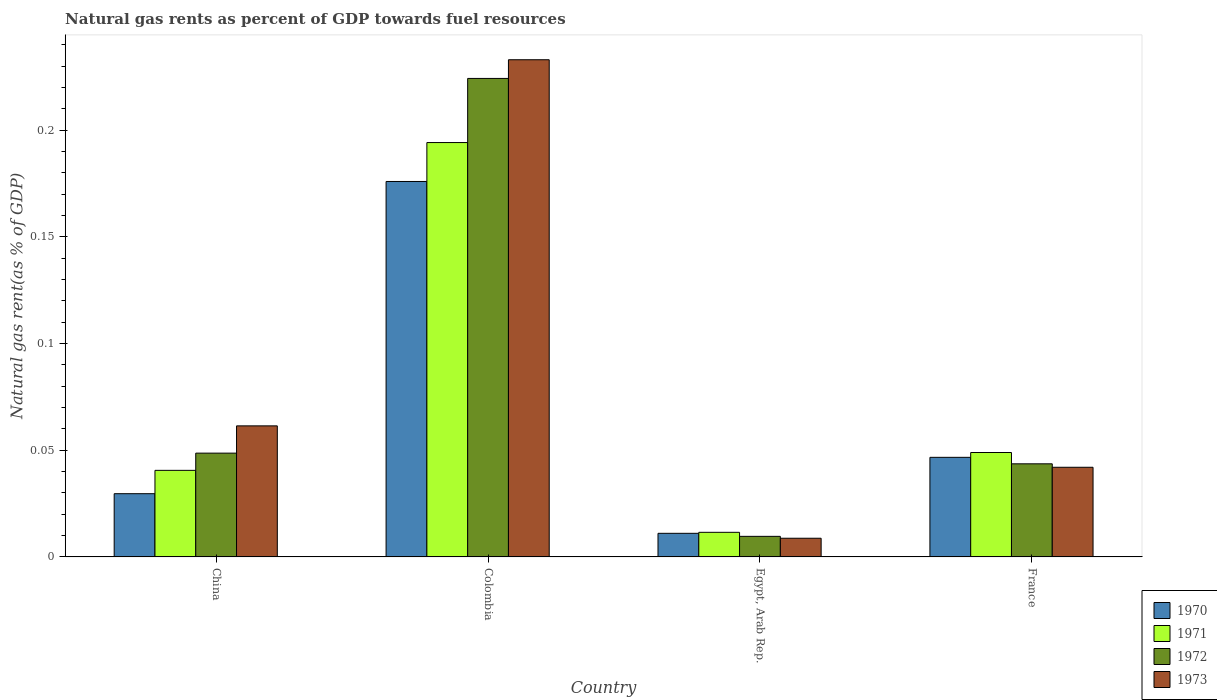How many groups of bars are there?
Ensure brevity in your answer.  4. How many bars are there on the 4th tick from the right?
Your response must be concise. 4. What is the label of the 4th group of bars from the left?
Provide a succinct answer. France. In how many cases, is the number of bars for a given country not equal to the number of legend labels?
Your answer should be compact. 0. What is the natural gas rent in 1973 in China?
Make the answer very short. 0.06. Across all countries, what is the maximum natural gas rent in 1973?
Offer a very short reply. 0.23. Across all countries, what is the minimum natural gas rent in 1973?
Offer a terse response. 0.01. In which country was the natural gas rent in 1970 maximum?
Offer a terse response. Colombia. In which country was the natural gas rent in 1972 minimum?
Offer a terse response. Egypt, Arab Rep. What is the total natural gas rent in 1973 in the graph?
Offer a terse response. 0.35. What is the difference between the natural gas rent in 1973 in China and that in Egypt, Arab Rep.?
Your response must be concise. 0.05. What is the difference between the natural gas rent in 1973 in China and the natural gas rent in 1971 in France?
Your response must be concise. 0.01. What is the average natural gas rent in 1971 per country?
Provide a short and direct response. 0.07. What is the difference between the natural gas rent of/in 1971 and natural gas rent of/in 1970 in Colombia?
Offer a terse response. 0.02. In how many countries, is the natural gas rent in 1971 greater than 0.04 %?
Offer a terse response. 3. What is the ratio of the natural gas rent in 1971 in China to that in France?
Offer a very short reply. 0.83. What is the difference between the highest and the second highest natural gas rent in 1970?
Offer a very short reply. 0.15. What is the difference between the highest and the lowest natural gas rent in 1971?
Provide a short and direct response. 0.18. Is it the case that in every country, the sum of the natural gas rent in 1972 and natural gas rent in 1970 is greater than the sum of natural gas rent in 1971 and natural gas rent in 1973?
Your answer should be compact. No. What does the 2nd bar from the right in Egypt, Arab Rep. represents?
Offer a terse response. 1972. How many countries are there in the graph?
Provide a succinct answer. 4. What is the difference between two consecutive major ticks on the Y-axis?
Provide a succinct answer. 0.05. Are the values on the major ticks of Y-axis written in scientific E-notation?
Provide a succinct answer. No. Does the graph contain any zero values?
Offer a terse response. No. Does the graph contain grids?
Your answer should be compact. No. Where does the legend appear in the graph?
Offer a very short reply. Bottom right. How many legend labels are there?
Your answer should be compact. 4. How are the legend labels stacked?
Provide a short and direct response. Vertical. What is the title of the graph?
Your answer should be compact. Natural gas rents as percent of GDP towards fuel resources. What is the label or title of the Y-axis?
Provide a short and direct response. Natural gas rent(as % of GDP). What is the Natural gas rent(as % of GDP) of 1970 in China?
Make the answer very short. 0.03. What is the Natural gas rent(as % of GDP) in 1971 in China?
Offer a very short reply. 0.04. What is the Natural gas rent(as % of GDP) of 1972 in China?
Give a very brief answer. 0.05. What is the Natural gas rent(as % of GDP) in 1973 in China?
Offer a terse response. 0.06. What is the Natural gas rent(as % of GDP) in 1970 in Colombia?
Your answer should be compact. 0.18. What is the Natural gas rent(as % of GDP) in 1971 in Colombia?
Offer a very short reply. 0.19. What is the Natural gas rent(as % of GDP) in 1972 in Colombia?
Your answer should be very brief. 0.22. What is the Natural gas rent(as % of GDP) of 1973 in Colombia?
Give a very brief answer. 0.23. What is the Natural gas rent(as % of GDP) in 1970 in Egypt, Arab Rep.?
Offer a very short reply. 0.01. What is the Natural gas rent(as % of GDP) of 1971 in Egypt, Arab Rep.?
Keep it short and to the point. 0.01. What is the Natural gas rent(as % of GDP) in 1972 in Egypt, Arab Rep.?
Offer a terse response. 0.01. What is the Natural gas rent(as % of GDP) in 1973 in Egypt, Arab Rep.?
Keep it short and to the point. 0.01. What is the Natural gas rent(as % of GDP) in 1970 in France?
Give a very brief answer. 0.05. What is the Natural gas rent(as % of GDP) of 1971 in France?
Your response must be concise. 0.05. What is the Natural gas rent(as % of GDP) of 1972 in France?
Offer a very short reply. 0.04. What is the Natural gas rent(as % of GDP) in 1973 in France?
Provide a short and direct response. 0.04. Across all countries, what is the maximum Natural gas rent(as % of GDP) in 1970?
Offer a terse response. 0.18. Across all countries, what is the maximum Natural gas rent(as % of GDP) of 1971?
Offer a very short reply. 0.19. Across all countries, what is the maximum Natural gas rent(as % of GDP) of 1972?
Offer a terse response. 0.22. Across all countries, what is the maximum Natural gas rent(as % of GDP) of 1973?
Your answer should be very brief. 0.23. Across all countries, what is the minimum Natural gas rent(as % of GDP) in 1970?
Provide a short and direct response. 0.01. Across all countries, what is the minimum Natural gas rent(as % of GDP) of 1971?
Provide a succinct answer. 0.01. Across all countries, what is the minimum Natural gas rent(as % of GDP) of 1972?
Give a very brief answer. 0.01. Across all countries, what is the minimum Natural gas rent(as % of GDP) of 1973?
Make the answer very short. 0.01. What is the total Natural gas rent(as % of GDP) in 1970 in the graph?
Make the answer very short. 0.26. What is the total Natural gas rent(as % of GDP) in 1971 in the graph?
Give a very brief answer. 0.3. What is the total Natural gas rent(as % of GDP) of 1972 in the graph?
Make the answer very short. 0.33. What is the total Natural gas rent(as % of GDP) in 1973 in the graph?
Offer a terse response. 0.35. What is the difference between the Natural gas rent(as % of GDP) of 1970 in China and that in Colombia?
Your response must be concise. -0.15. What is the difference between the Natural gas rent(as % of GDP) of 1971 in China and that in Colombia?
Your answer should be compact. -0.15. What is the difference between the Natural gas rent(as % of GDP) of 1972 in China and that in Colombia?
Your response must be concise. -0.18. What is the difference between the Natural gas rent(as % of GDP) in 1973 in China and that in Colombia?
Your answer should be compact. -0.17. What is the difference between the Natural gas rent(as % of GDP) in 1970 in China and that in Egypt, Arab Rep.?
Offer a terse response. 0.02. What is the difference between the Natural gas rent(as % of GDP) in 1971 in China and that in Egypt, Arab Rep.?
Your answer should be compact. 0.03. What is the difference between the Natural gas rent(as % of GDP) of 1972 in China and that in Egypt, Arab Rep.?
Make the answer very short. 0.04. What is the difference between the Natural gas rent(as % of GDP) of 1973 in China and that in Egypt, Arab Rep.?
Offer a very short reply. 0.05. What is the difference between the Natural gas rent(as % of GDP) of 1970 in China and that in France?
Ensure brevity in your answer.  -0.02. What is the difference between the Natural gas rent(as % of GDP) in 1971 in China and that in France?
Provide a succinct answer. -0.01. What is the difference between the Natural gas rent(as % of GDP) of 1972 in China and that in France?
Provide a short and direct response. 0.01. What is the difference between the Natural gas rent(as % of GDP) in 1973 in China and that in France?
Provide a short and direct response. 0.02. What is the difference between the Natural gas rent(as % of GDP) in 1970 in Colombia and that in Egypt, Arab Rep.?
Your response must be concise. 0.16. What is the difference between the Natural gas rent(as % of GDP) in 1971 in Colombia and that in Egypt, Arab Rep.?
Your response must be concise. 0.18. What is the difference between the Natural gas rent(as % of GDP) of 1972 in Colombia and that in Egypt, Arab Rep.?
Offer a terse response. 0.21. What is the difference between the Natural gas rent(as % of GDP) of 1973 in Colombia and that in Egypt, Arab Rep.?
Provide a succinct answer. 0.22. What is the difference between the Natural gas rent(as % of GDP) in 1970 in Colombia and that in France?
Offer a very short reply. 0.13. What is the difference between the Natural gas rent(as % of GDP) in 1971 in Colombia and that in France?
Keep it short and to the point. 0.15. What is the difference between the Natural gas rent(as % of GDP) in 1972 in Colombia and that in France?
Your answer should be compact. 0.18. What is the difference between the Natural gas rent(as % of GDP) in 1973 in Colombia and that in France?
Provide a short and direct response. 0.19. What is the difference between the Natural gas rent(as % of GDP) in 1970 in Egypt, Arab Rep. and that in France?
Give a very brief answer. -0.04. What is the difference between the Natural gas rent(as % of GDP) of 1971 in Egypt, Arab Rep. and that in France?
Your answer should be very brief. -0.04. What is the difference between the Natural gas rent(as % of GDP) of 1972 in Egypt, Arab Rep. and that in France?
Give a very brief answer. -0.03. What is the difference between the Natural gas rent(as % of GDP) of 1973 in Egypt, Arab Rep. and that in France?
Your answer should be compact. -0.03. What is the difference between the Natural gas rent(as % of GDP) in 1970 in China and the Natural gas rent(as % of GDP) in 1971 in Colombia?
Give a very brief answer. -0.16. What is the difference between the Natural gas rent(as % of GDP) in 1970 in China and the Natural gas rent(as % of GDP) in 1972 in Colombia?
Your answer should be compact. -0.19. What is the difference between the Natural gas rent(as % of GDP) of 1970 in China and the Natural gas rent(as % of GDP) of 1973 in Colombia?
Give a very brief answer. -0.2. What is the difference between the Natural gas rent(as % of GDP) of 1971 in China and the Natural gas rent(as % of GDP) of 1972 in Colombia?
Give a very brief answer. -0.18. What is the difference between the Natural gas rent(as % of GDP) of 1971 in China and the Natural gas rent(as % of GDP) of 1973 in Colombia?
Provide a succinct answer. -0.19. What is the difference between the Natural gas rent(as % of GDP) in 1972 in China and the Natural gas rent(as % of GDP) in 1973 in Colombia?
Your answer should be very brief. -0.18. What is the difference between the Natural gas rent(as % of GDP) in 1970 in China and the Natural gas rent(as % of GDP) in 1971 in Egypt, Arab Rep.?
Your answer should be compact. 0.02. What is the difference between the Natural gas rent(as % of GDP) of 1970 in China and the Natural gas rent(as % of GDP) of 1973 in Egypt, Arab Rep.?
Provide a succinct answer. 0.02. What is the difference between the Natural gas rent(as % of GDP) in 1971 in China and the Natural gas rent(as % of GDP) in 1972 in Egypt, Arab Rep.?
Keep it short and to the point. 0.03. What is the difference between the Natural gas rent(as % of GDP) in 1971 in China and the Natural gas rent(as % of GDP) in 1973 in Egypt, Arab Rep.?
Provide a succinct answer. 0.03. What is the difference between the Natural gas rent(as % of GDP) of 1972 in China and the Natural gas rent(as % of GDP) of 1973 in Egypt, Arab Rep.?
Provide a succinct answer. 0.04. What is the difference between the Natural gas rent(as % of GDP) of 1970 in China and the Natural gas rent(as % of GDP) of 1971 in France?
Your answer should be very brief. -0.02. What is the difference between the Natural gas rent(as % of GDP) in 1970 in China and the Natural gas rent(as % of GDP) in 1972 in France?
Provide a short and direct response. -0.01. What is the difference between the Natural gas rent(as % of GDP) in 1970 in China and the Natural gas rent(as % of GDP) in 1973 in France?
Offer a very short reply. -0.01. What is the difference between the Natural gas rent(as % of GDP) in 1971 in China and the Natural gas rent(as % of GDP) in 1972 in France?
Ensure brevity in your answer.  -0. What is the difference between the Natural gas rent(as % of GDP) in 1971 in China and the Natural gas rent(as % of GDP) in 1973 in France?
Offer a very short reply. -0. What is the difference between the Natural gas rent(as % of GDP) of 1972 in China and the Natural gas rent(as % of GDP) of 1973 in France?
Keep it short and to the point. 0.01. What is the difference between the Natural gas rent(as % of GDP) of 1970 in Colombia and the Natural gas rent(as % of GDP) of 1971 in Egypt, Arab Rep.?
Your response must be concise. 0.16. What is the difference between the Natural gas rent(as % of GDP) of 1970 in Colombia and the Natural gas rent(as % of GDP) of 1972 in Egypt, Arab Rep.?
Your answer should be compact. 0.17. What is the difference between the Natural gas rent(as % of GDP) in 1970 in Colombia and the Natural gas rent(as % of GDP) in 1973 in Egypt, Arab Rep.?
Give a very brief answer. 0.17. What is the difference between the Natural gas rent(as % of GDP) in 1971 in Colombia and the Natural gas rent(as % of GDP) in 1972 in Egypt, Arab Rep.?
Offer a terse response. 0.18. What is the difference between the Natural gas rent(as % of GDP) of 1971 in Colombia and the Natural gas rent(as % of GDP) of 1973 in Egypt, Arab Rep.?
Your response must be concise. 0.19. What is the difference between the Natural gas rent(as % of GDP) in 1972 in Colombia and the Natural gas rent(as % of GDP) in 1973 in Egypt, Arab Rep.?
Give a very brief answer. 0.22. What is the difference between the Natural gas rent(as % of GDP) in 1970 in Colombia and the Natural gas rent(as % of GDP) in 1971 in France?
Provide a short and direct response. 0.13. What is the difference between the Natural gas rent(as % of GDP) in 1970 in Colombia and the Natural gas rent(as % of GDP) in 1972 in France?
Offer a very short reply. 0.13. What is the difference between the Natural gas rent(as % of GDP) in 1970 in Colombia and the Natural gas rent(as % of GDP) in 1973 in France?
Provide a succinct answer. 0.13. What is the difference between the Natural gas rent(as % of GDP) of 1971 in Colombia and the Natural gas rent(as % of GDP) of 1972 in France?
Ensure brevity in your answer.  0.15. What is the difference between the Natural gas rent(as % of GDP) of 1971 in Colombia and the Natural gas rent(as % of GDP) of 1973 in France?
Provide a succinct answer. 0.15. What is the difference between the Natural gas rent(as % of GDP) in 1972 in Colombia and the Natural gas rent(as % of GDP) in 1973 in France?
Provide a short and direct response. 0.18. What is the difference between the Natural gas rent(as % of GDP) in 1970 in Egypt, Arab Rep. and the Natural gas rent(as % of GDP) in 1971 in France?
Provide a succinct answer. -0.04. What is the difference between the Natural gas rent(as % of GDP) of 1970 in Egypt, Arab Rep. and the Natural gas rent(as % of GDP) of 1972 in France?
Offer a terse response. -0.03. What is the difference between the Natural gas rent(as % of GDP) of 1970 in Egypt, Arab Rep. and the Natural gas rent(as % of GDP) of 1973 in France?
Ensure brevity in your answer.  -0.03. What is the difference between the Natural gas rent(as % of GDP) of 1971 in Egypt, Arab Rep. and the Natural gas rent(as % of GDP) of 1972 in France?
Your answer should be very brief. -0.03. What is the difference between the Natural gas rent(as % of GDP) of 1971 in Egypt, Arab Rep. and the Natural gas rent(as % of GDP) of 1973 in France?
Keep it short and to the point. -0.03. What is the difference between the Natural gas rent(as % of GDP) of 1972 in Egypt, Arab Rep. and the Natural gas rent(as % of GDP) of 1973 in France?
Your response must be concise. -0.03. What is the average Natural gas rent(as % of GDP) of 1970 per country?
Offer a very short reply. 0.07. What is the average Natural gas rent(as % of GDP) in 1971 per country?
Provide a short and direct response. 0.07. What is the average Natural gas rent(as % of GDP) of 1972 per country?
Your answer should be compact. 0.08. What is the average Natural gas rent(as % of GDP) in 1973 per country?
Offer a very short reply. 0.09. What is the difference between the Natural gas rent(as % of GDP) in 1970 and Natural gas rent(as % of GDP) in 1971 in China?
Provide a succinct answer. -0.01. What is the difference between the Natural gas rent(as % of GDP) in 1970 and Natural gas rent(as % of GDP) in 1972 in China?
Ensure brevity in your answer.  -0.02. What is the difference between the Natural gas rent(as % of GDP) in 1970 and Natural gas rent(as % of GDP) in 1973 in China?
Your response must be concise. -0.03. What is the difference between the Natural gas rent(as % of GDP) in 1971 and Natural gas rent(as % of GDP) in 1972 in China?
Keep it short and to the point. -0.01. What is the difference between the Natural gas rent(as % of GDP) in 1971 and Natural gas rent(as % of GDP) in 1973 in China?
Keep it short and to the point. -0.02. What is the difference between the Natural gas rent(as % of GDP) of 1972 and Natural gas rent(as % of GDP) of 1973 in China?
Your response must be concise. -0.01. What is the difference between the Natural gas rent(as % of GDP) in 1970 and Natural gas rent(as % of GDP) in 1971 in Colombia?
Make the answer very short. -0.02. What is the difference between the Natural gas rent(as % of GDP) of 1970 and Natural gas rent(as % of GDP) of 1972 in Colombia?
Keep it short and to the point. -0.05. What is the difference between the Natural gas rent(as % of GDP) in 1970 and Natural gas rent(as % of GDP) in 1973 in Colombia?
Give a very brief answer. -0.06. What is the difference between the Natural gas rent(as % of GDP) in 1971 and Natural gas rent(as % of GDP) in 1972 in Colombia?
Offer a very short reply. -0.03. What is the difference between the Natural gas rent(as % of GDP) in 1971 and Natural gas rent(as % of GDP) in 1973 in Colombia?
Provide a succinct answer. -0.04. What is the difference between the Natural gas rent(as % of GDP) in 1972 and Natural gas rent(as % of GDP) in 1973 in Colombia?
Offer a very short reply. -0.01. What is the difference between the Natural gas rent(as % of GDP) in 1970 and Natural gas rent(as % of GDP) in 1971 in Egypt, Arab Rep.?
Make the answer very short. -0. What is the difference between the Natural gas rent(as % of GDP) of 1970 and Natural gas rent(as % of GDP) of 1972 in Egypt, Arab Rep.?
Offer a terse response. 0. What is the difference between the Natural gas rent(as % of GDP) in 1970 and Natural gas rent(as % of GDP) in 1973 in Egypt, Arab Rep.?
Your response must be concise. 0. What is the difference between the Natural gas rent(as % of GDP) in 1971 and Natural gas rent(as % of GDP) in 1972 in Egypt, Arab Rep.?
Your response must be concise. 0. What is the difference between the Natural gas rent(as % of GDP) of 1971 and Natural gas rent(as % of GDP) of 1973 in Egypt, Arab Rep.?
Provide a short and direct response. 0. What is the difference between the Natural gas rent(as % of GDP) in 1972 and Natural gas rent(as % of GDP) in 1973 in Egypt, Arab Rep.?
Make the answer very short. 0. What is the difference between the Natural gas rent(as % of GDP) in 1970 and Natural gas rent(as % of GDP) in 1971 in France?
Your answer should be compact. -0. What is the difference between the Natural gas rent(as % of GDP) in 1970 and Natural gas rent(as % of GDP) in 1972 in France?
Provide a succinct answer. 0. What is the difference between the Natural gas rent(as % of GDP) in 1970 and Natural gas rent(as % of GDP) in 1973 in France?
Offer a terse response. 0. What is the difference between the Natural gas rent(as % of GDP) in 1971 and Natural gas rent(as % of GDP) in 1972 in France?
Your answer should be compact. 0.01. What is the difference between the Natural gas rent(as % of GDP) in 1971 and Natural gas rent(as % of GDP) in 1973 in France?
Make the answer very short. 0.01. What is the difference between the Natural gas rent(as % of GDP) of 1972 and Natural gas rent(as % of GDP) of 1973 in France?
Make the answer very short. 0. What is the ratio of the Natural gas rent(as % of GDP) in 1970 in China to that in Colombia?
Give a very brief answer. 0.17. What is the ratio of the Natural gas rent(as % of GDP) of 1971 in China to that in Colombia?
Make the answer very short. 0.21. What is the ratio of the Natural gas rent(as % of GDP) of 1972 in China to that in Colombia?
Provide a short and direct response. 0.22. What is the ratio of the Natural gas rent(as % of GDP) in 1973 in China to that in Colombia?
Offer a very short reply. 0.26. What is the ratio of the Natural gas rent(as % of GDP) of 1970 in China to that in Egypt, Arab Rep.?
Provide a short and direct response. 2.68. What is the ratio of the Natural gas rent(as % of GDP) of 1971 in China to that in Egypt, Arab Rep.?
Make the answer very short. 3.52. What is the ratio of the Natural gas rent(as % of GDP) in 1972 in China to that in Egypt, Arab Rep.?
Provide a succinct answer. 5.04. What is the ratio of the Natural gas rent(as % of GDP) in 1973 in China to that in Egypt, Arab Rep.?
Provide a succinct answer. 7.01. What is the ratio of the Natural gas rent(as % of GDP) in 1970 in China to that in France?
Offer a terse response. 0.64. What is the ratio of the Natural gas rent(as % of GDP) of 1971 in China to that in France?
Offer a terse response. 0.83. What is the ratio of the Natural gas rent(as % of GDP) of 1972 in China to that in France?
Provide a short and direct response. 1.11. What is the ratio of the Natural gas rent(as % of GDP) of 1973 in China to that in France?
Your response must be concise. 1.46. What is the ratio of the Natural gas rent(as % of GDP) in 1970 in Colombia to that in Egypt, Arab Rep.?
Ensure brevity in your answer.  15.9. What is the ratio of the Natural gas rent(as % of GDP) in 1971 in Colombia to that in Egypt, Arab Rep.?
Give a very brief answer. 16.84. What is the ratio of the Natural gas rent(as % of GDP) of 1972 in Colombia to that in Egypt, Arab Rep.?
Your response must be concise. 23.25. What is the ratio of the Natural gas rent(as % of GDP) of 1973 in Colombia to that in Egypt, Arab Rep.?
Provide a succinct answer. 26.6. What is the ratio of the Natural gas rent(as % of GDP) of 1970 in Colombia to that in France?
Ensure brevity in your answer.  3.77. What is the ratio of the Natural gas rent(as % of GDP) in 1971 in Colombia to that in France?
Ensure brevity in your answer.  3.97. What is the ratio of the Natural gas rent(as % of GDP) in 1972 in Colombia to that in France?
Your answer should be compact. 5.14. What is the ratio of the Natural gas rent(as % of GDP) of 1973 in Colombia to that in France?
Your answer should be very brief. 5.55. What is the ratio of the Natural gas rent(as % of GDP) in 1970 in Egypt, Arab Rep. to that in France?
Give a very brief answer. 0.24. What is the ratio of the Natural gas rent(as % of GDP) of 1971 in Egypt, Arab Rep. to that in France?
Your response must be concise. 0.24. What is the ratio of the Natural gas rent(as % of GDP) of 1972 in Egypt, Arab Rep. to that in France?
Make the answer very short. 0.22. What is the ratio of the Natural gas rent(as % of GDP) in 1973 in Egypt, Arab Rep. to that in France?
Your response must be concise. 0.21. What is the difference between the highest and the second highest Natural gas rent(as % of GDP) in 1970?
Provide a succinct answer. 0.13. What is the difference between the highest and the second highest Natural gas rent(as % of GDP) of 1971?
Offer a terse response. 0.15. What is the difference between the highest and the second highest Natural gas rent(as % of GDP) of 1972?
Provide a succinct answer. 0.18. What is the difference between the highest and the second highest Natural gas rent(as % of GDP) of 1973?
Your answer should be very brief. 0.17. What is the difference between the highest and the lowest Natural gas rent(as % of GDP) of 1970?
Provide a short and direct response. 0.16. What is the difference between the highest and the lowest Natural gas rent(as % of GDP) of 1971?
Your answer should be very brief. 0.18. What is the difference between the highest and the lowest Natural gas rent(as % of GDP) of 1972?
Your answer should be very brief. 0.21. What is the difference between the highest and the lowest Natural gas rent(as % of GDP) of 1973?
Make the answer very short. 0.22. 